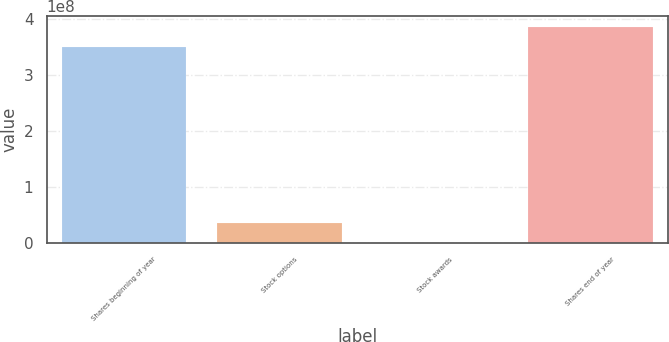<chart> <loc_0><loc_0><loc_500><loc_500><bar_chart><fcel>Shares beginning of year<fcel>Stock options<fcel>Stock awards<fcel>Shares end of year<nl><fcel>3.5034e+08<fcel>3.5701e+07<fcel>489100<fcel>3.85552e+08<nl></chart> 